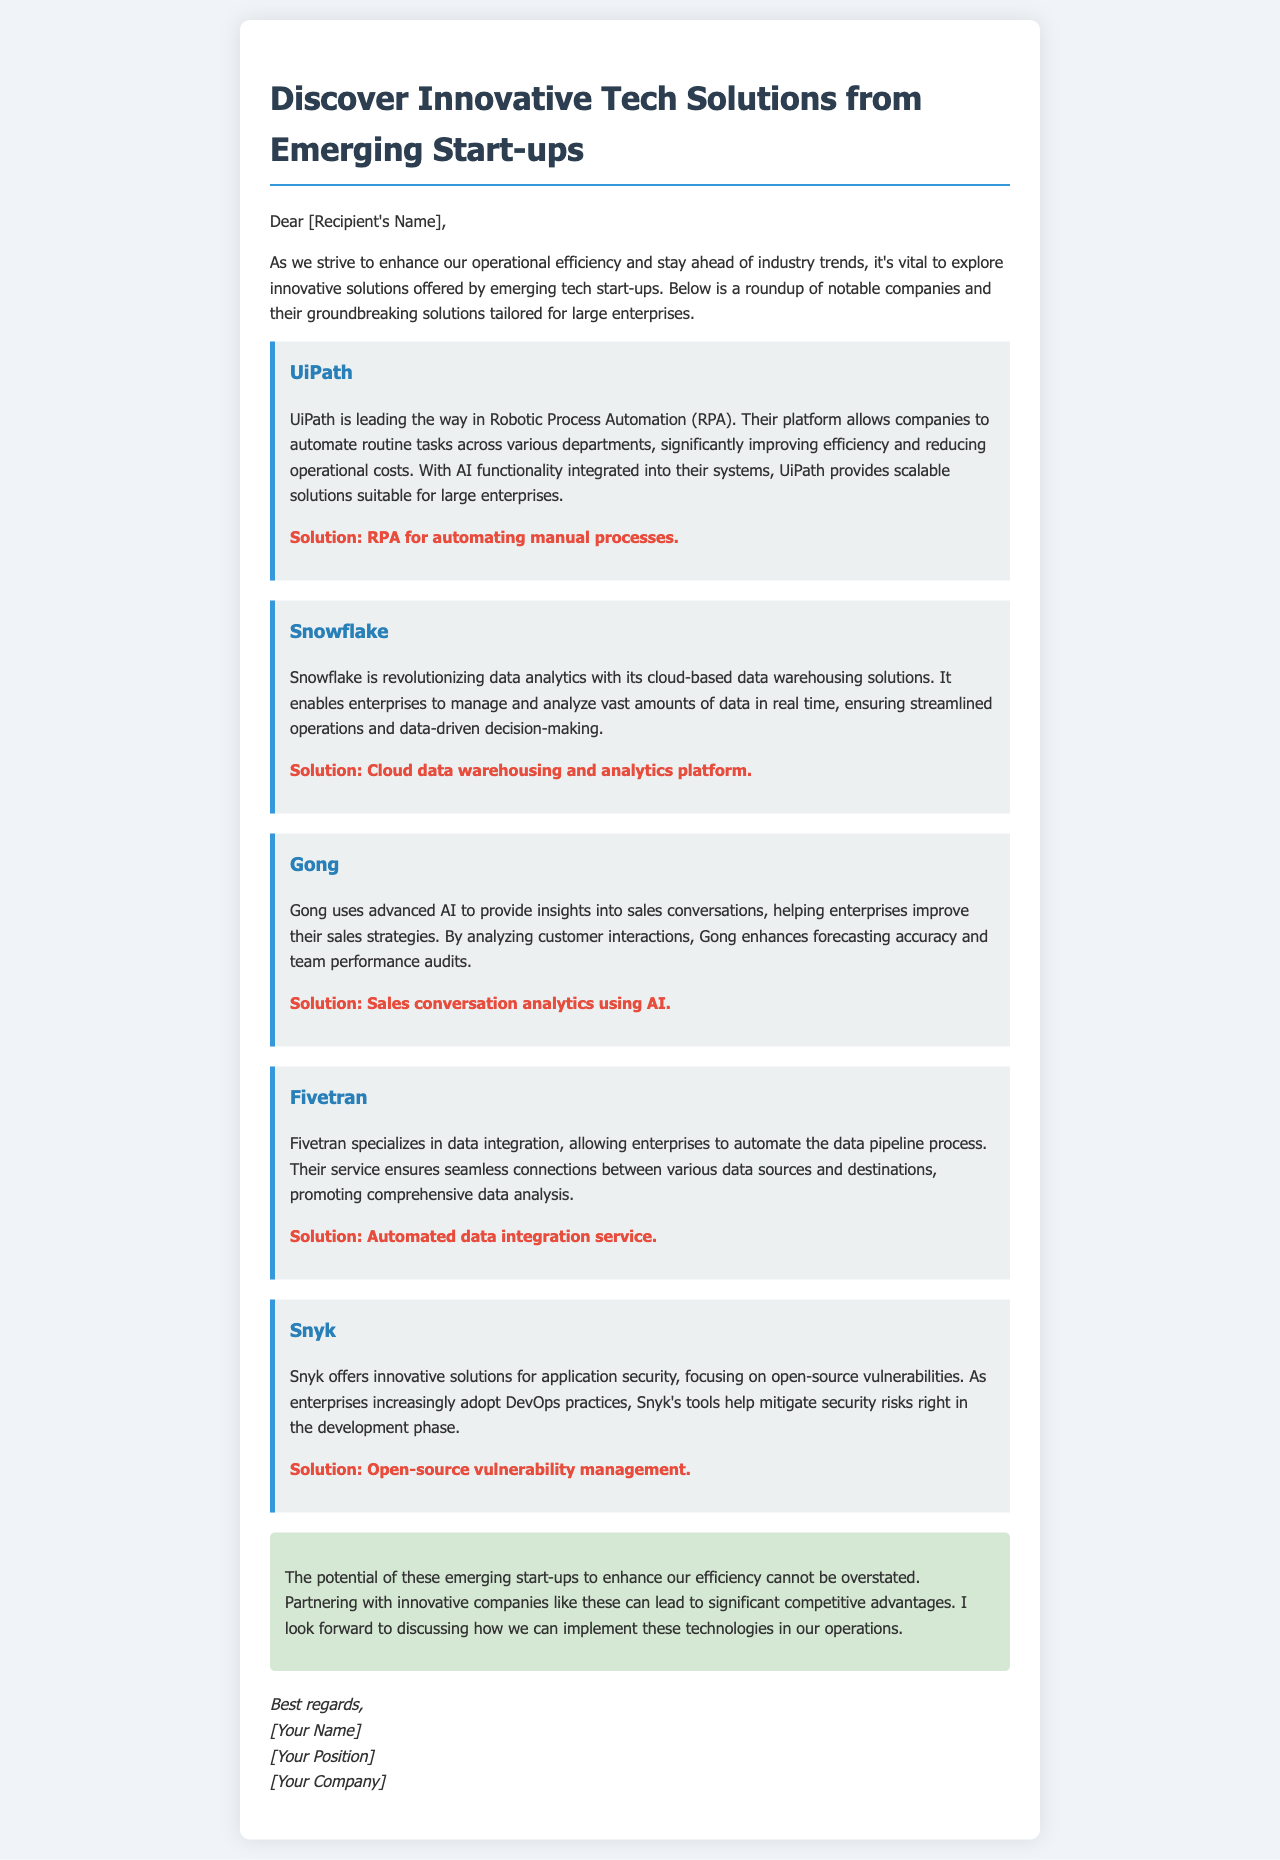What company is known for Robotic Process Automation? The document mentions UiPath as the leader in Robotic Process Automation (RPA).
Answer: UiPath What solution does Gong provide? Gong's solution involves sales conversation analytics using AI.
Answer: Sales conversation analytics using AI What is the primary focus of Snyk? According to the document, Snyk focuses on open-source vulnerabilities and application security.
Answer: Open-source vulnerability management What does Snowflake specialize in? The document states that Snowflake specializes in cloud-based data warehousing solutions.
Answer: Cloud data warehousing and analytics platform How does Fivetran assist enterprises? Fivetran assists enterprises by automating the data pipeline process for data integration.
Answer: Automated data integration service What is the conclusion about the potential of emerging start-ups? The conclusion reflects that partnering with innovative companies can lead to significant competitive advantages.
Answer: Significant competitive advantages What type of technology does UiPath integrate into their systems? The document mentions that UiPath has integrated AI functionality into their systems.
Answer: AI functionality Who wrote the email? The email is signed off with the placeholder "[Your Name]", indicating the sender is unspecified.
Answer: [Your Name] 